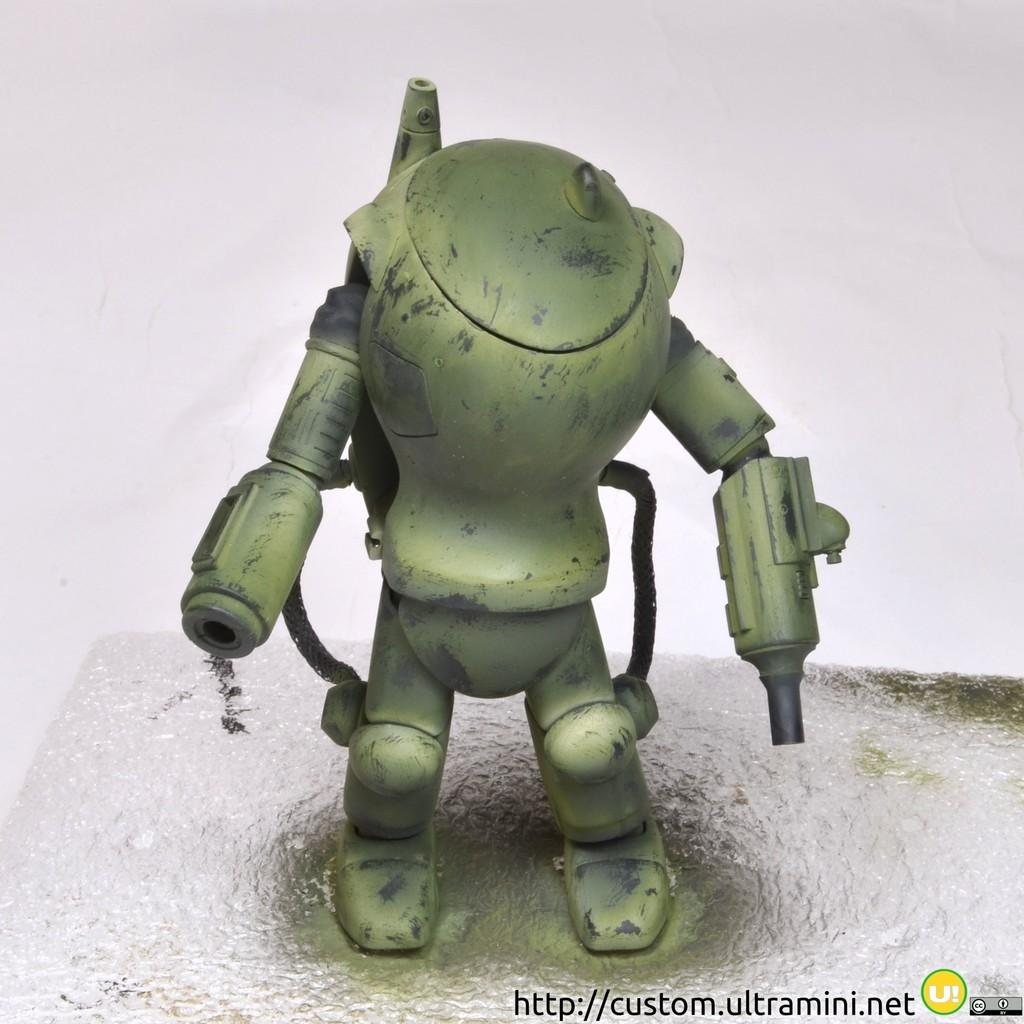What object can be seen in the image? There is a toy in the image. What additional information is present at the bottom of the image? There is text and a watermark at the bottom of the image. What can be seen in the background of the image? There is a wall in the background of the image. What type of treatment is being administered to the toy in the image? There is no treatment being administered to the toy in the image; it is simply a toy sitting in the scene. 